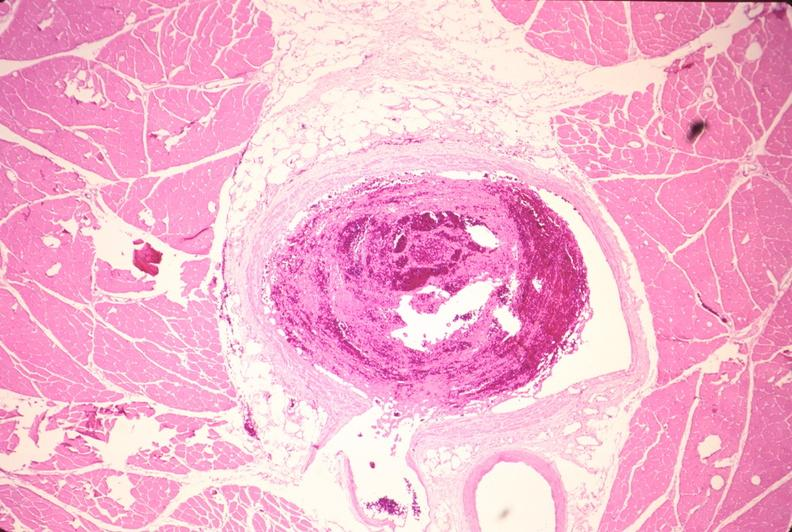what is present?
Answer the question using a single word or phrase. Vasculature 